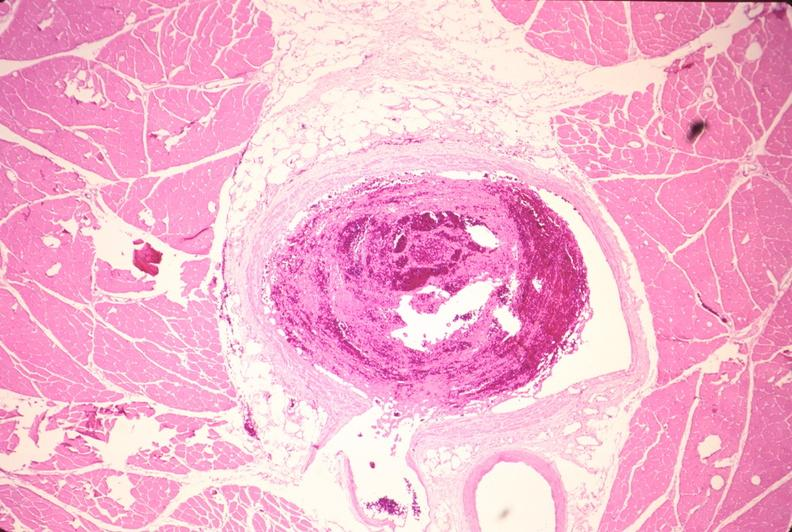what is present?
Answer the question using a single word or phrase. Vasculature 